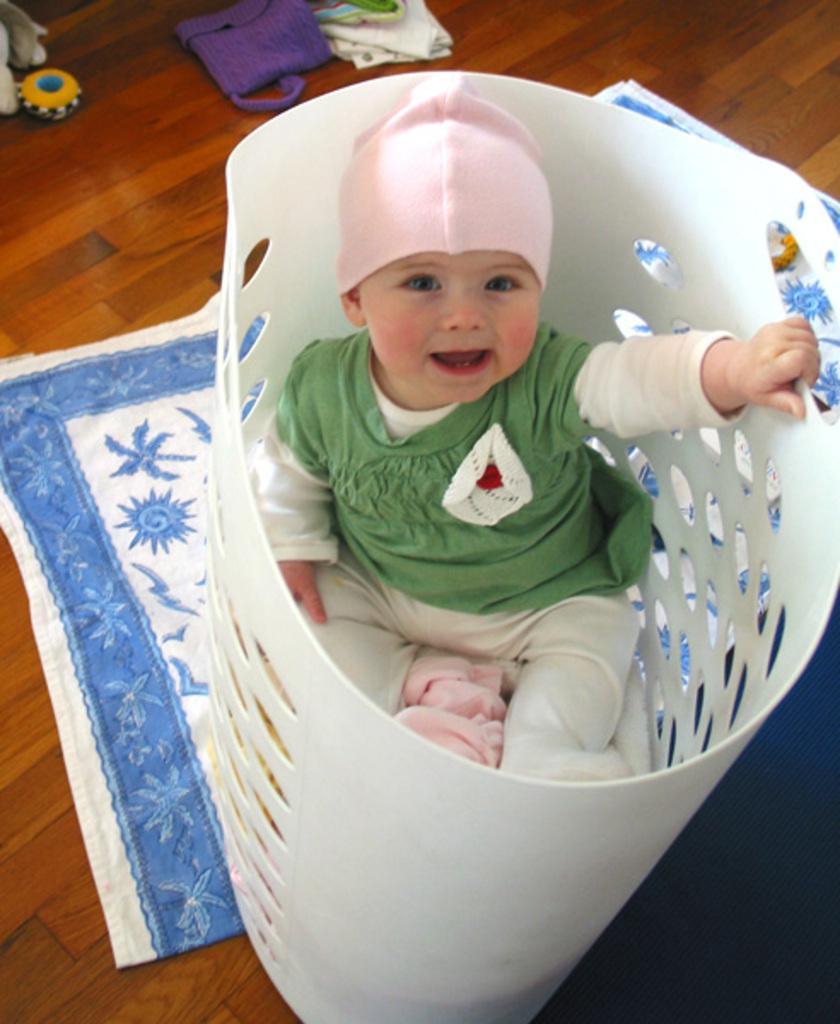Could you give a brief overview of what you see in this image? Here we can see a kid in a basket. This is floor and there are clothes. 